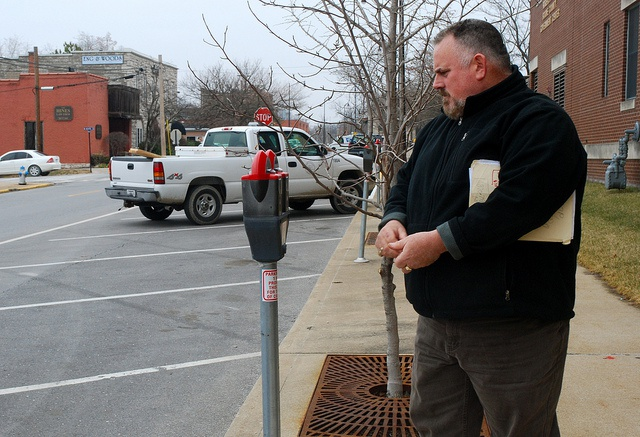Describe the objects in this image and their specific colors. I can see people in white, black, brown, gray, and maroon tones, truck in white, black, darkgray, gray, and lightgray tones, parking meter in white, black, gray, maroon, and purple tones, car in white, lightgray, gray, darkgray, and black tones, and car in white, black, gray, darkgray, and blue tones in this image. 